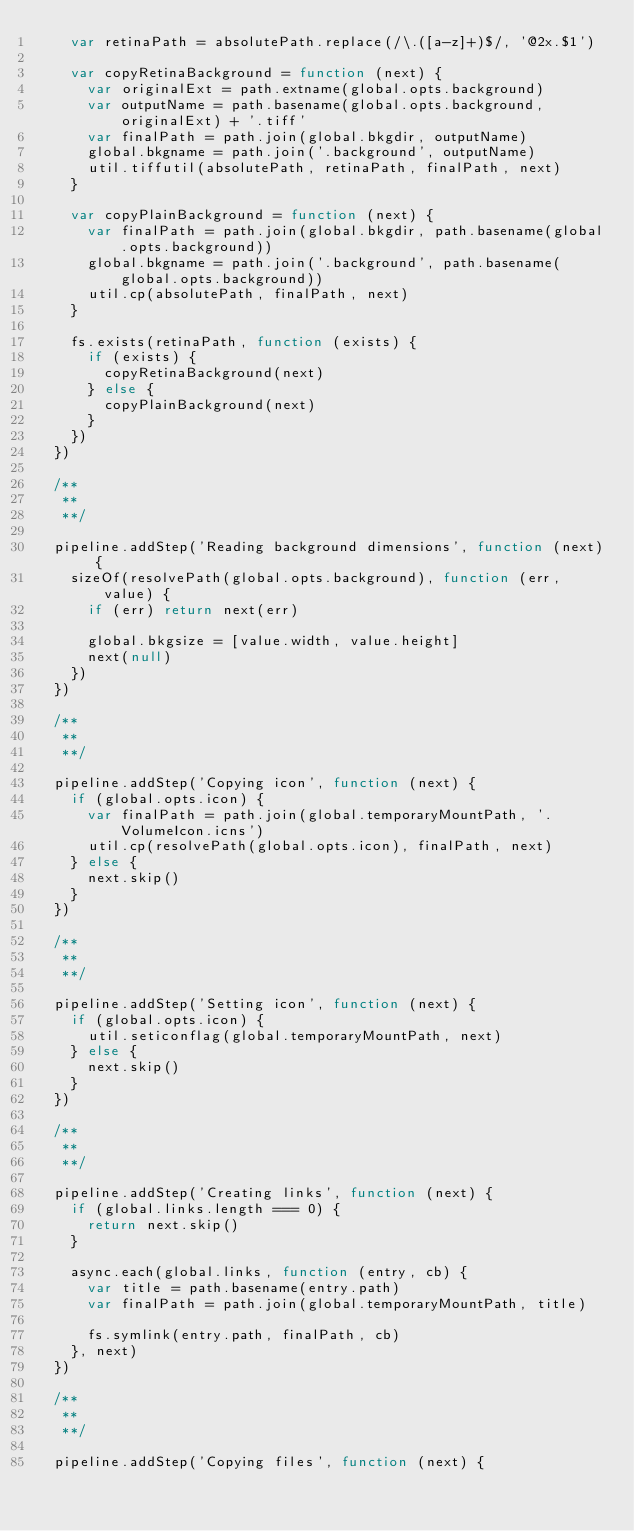Convert code to text. <code><loc_0><loc_0><loc_500><loc_500><_JavaScript_>    var retinaPath = absolutePath.replace(/\.([a-z]+)$/, '@2x.$1')

    var copyRetinaBackground = function (next) {
      var originalExt = path.extname(global.opts.background)
      var outputName = path.basename(global.opts.background, originalExt) + '.tiff'
      var finalPath = path.join(global.bkgdir, outputName)
      global.bkgname = path.join('.background', outputName)
      util.tiffutil(absolutePath, retinaPath, finalPath, next)
    }

    var copyPlainBackground = function (next) {
      var finalPath = path.join(global.bkgdir, path.basename(global.opts.background))
      global.bkgname = path.join('.background', path.basename(global.opts.background))
      util.cp(absolutePath, finalPath, next)
    }

    fs.exists(retinaPath, function (exists) {
      if (exists) {
        copyRetinaBackground(next)
      } else {
        copyPlainBackground(next)
      }
    })
  })

  /**
   **
   **/

  pipeline.addStep('Reading background dimensions', function (next) {
    sizeOf(resolvePath(global.opts.background), function (err, value) {
      if (err) return next(err)

      global.bkgsize = [value.width, value.height]
      next(null)
    })
  })

  /**
   **
   **/

  pipeline.addStep('Copying icon', function (next) {
    if (global.opts.icon) {
      var finalPath = path.join(global.temporaryMountPath, '.VolumeIcon.icns')
      util.cp(resolvePath(global.opts.icon), finalPath, next)
    } else {
      next.skip()
    }
  })

  /**
   **
   **/

  pipeline.addStep('Setting icon', function (next) {
    if (global.opts.icon) {
      util.seticonflag(global.temporaryMountPath, next)
    } else {
      next.skip()
    }
  })

  /**
   **
   **/

  pipeline.addStep('Creating links', function (next) {
    if (global.links.length === 0) {
      return next.skip()
    }

    async.each(global.links, function (entry, cb) {
      var title = path.basename(entry.path)
      var finalPath = path.join(global.temporaryMountPath, title)

      fs.symlink(entry.path, finalPath, cb)
    }, next)
  })

  /**
   **
   **/

  pipeline.addStep('Copying files', function (next) {</code> 